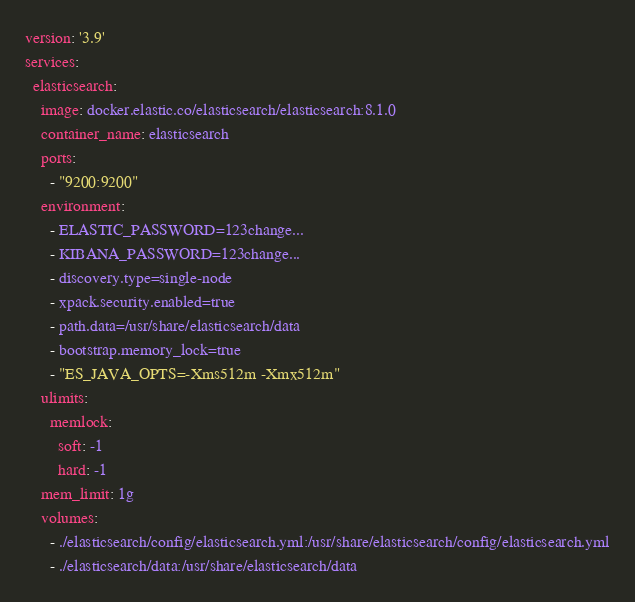Convert code to text. <code><loc_0><loc_0><loc_500><loc_500><_YAML_>version: '3.9'
services:
  elasticsearch:
    image: docker.elastic.co/elasticsearch/elasticsearch:8.1.0
    container_name: elasticsearch
    ports: 
      - "9200:9200"
    environment:
      - ELASTIC_PASSWORD=123change...
      - KIBANA_PASSWORD=123change...  
      - discovery.type=single-node
      - xpack.security.enabled=true
      - path.data=/usr/share/elasticsearch/data
      - bootstrap.memory_lock=true
      - "ES_JAVA_OPTS=-Xms512m -Xmx512m"
    ulimits:
      memlock:
        soft: -1
        hard: -1
    mem_limit: 1g
    volumes:
      - ./elasticsearch/config/elasticsearch.yml:/usr/share/elasticsearch/config/elasticsearch.yml
      - ./elasticsearch/data:/usr/share/elasticsearch/data</code> 